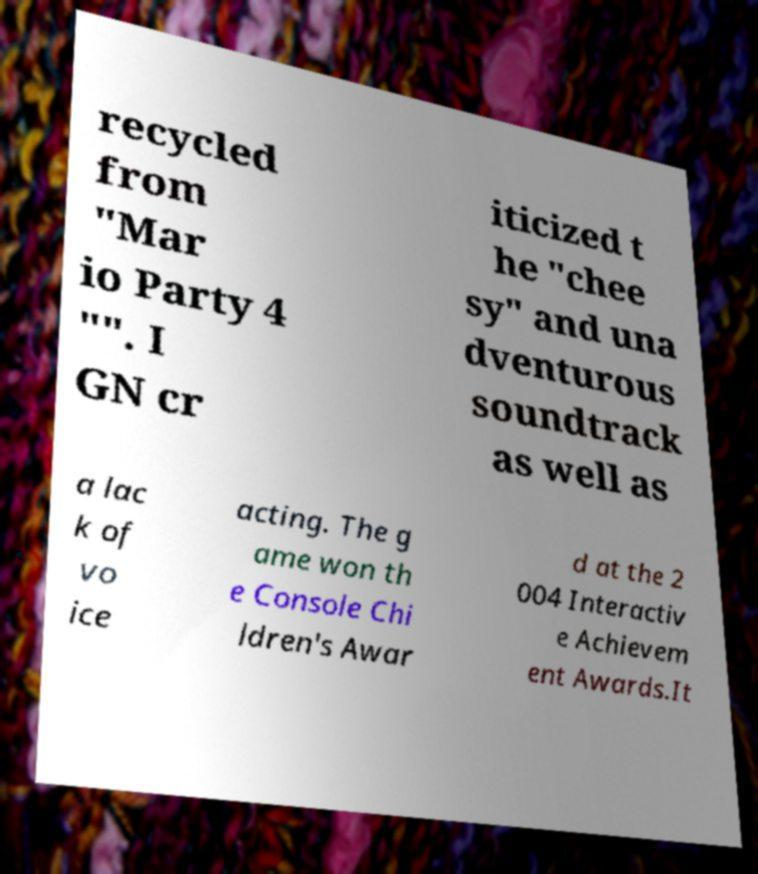Could you assist in decoding the text presented in this image and type it out clearly? recycled from "Mar io Party 4 "". I GN cr iticized t he "chee sy" and una dventurous soundtrack as well as a lac k of vo ice acting. The g ame won th e Console Chi ldren's Awar d at the 2 004 Interactiv e Achievem ent Awards.It 